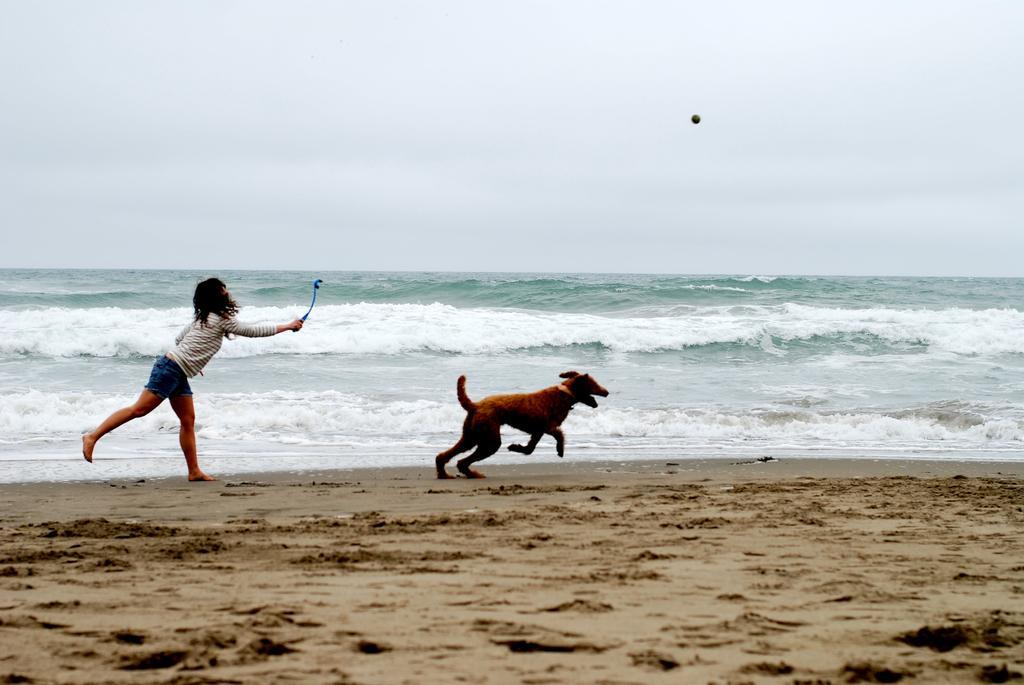How would you summarize this image in a sentence or two? In the image we can see a woman wearing clothes and holding a stick in hand. We can even see a dog running. Here we can see the beach and the sky. 